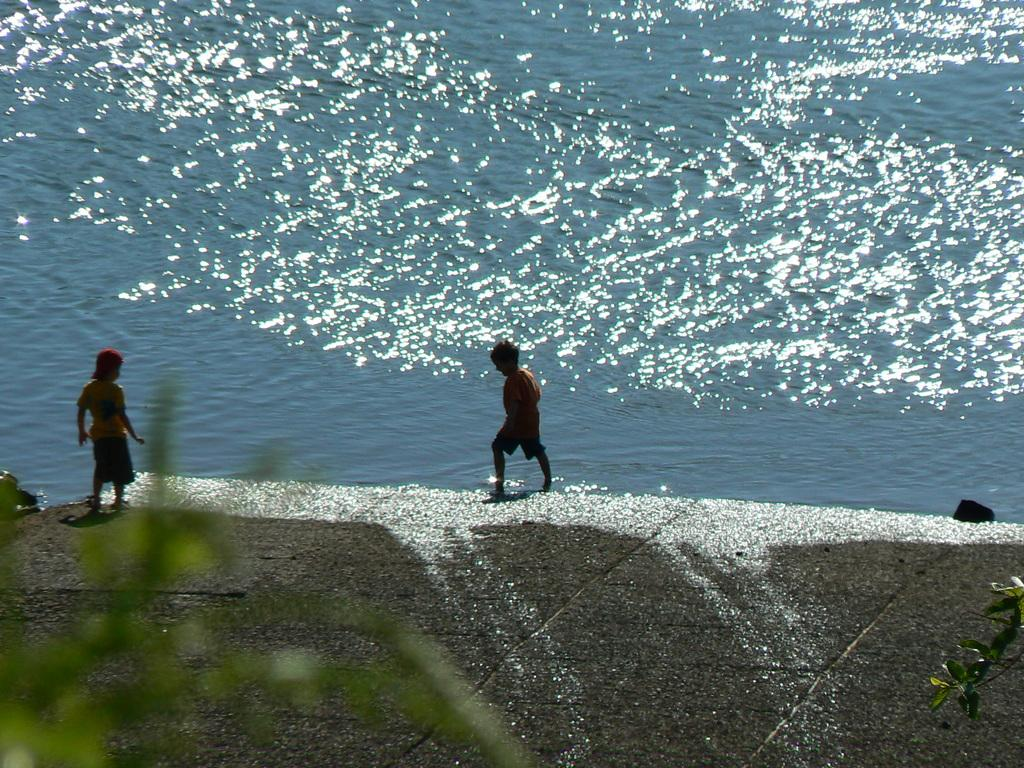Who is present in the image? There are children in the image. Where are the children located? The children are standing on the river bed. What can be seen in the background of the image? Water is visible in the image. What type of tin can be seen on the river bank in the image? There is no tin present in the image; it features children standing on the river bed with water visible in the background. 